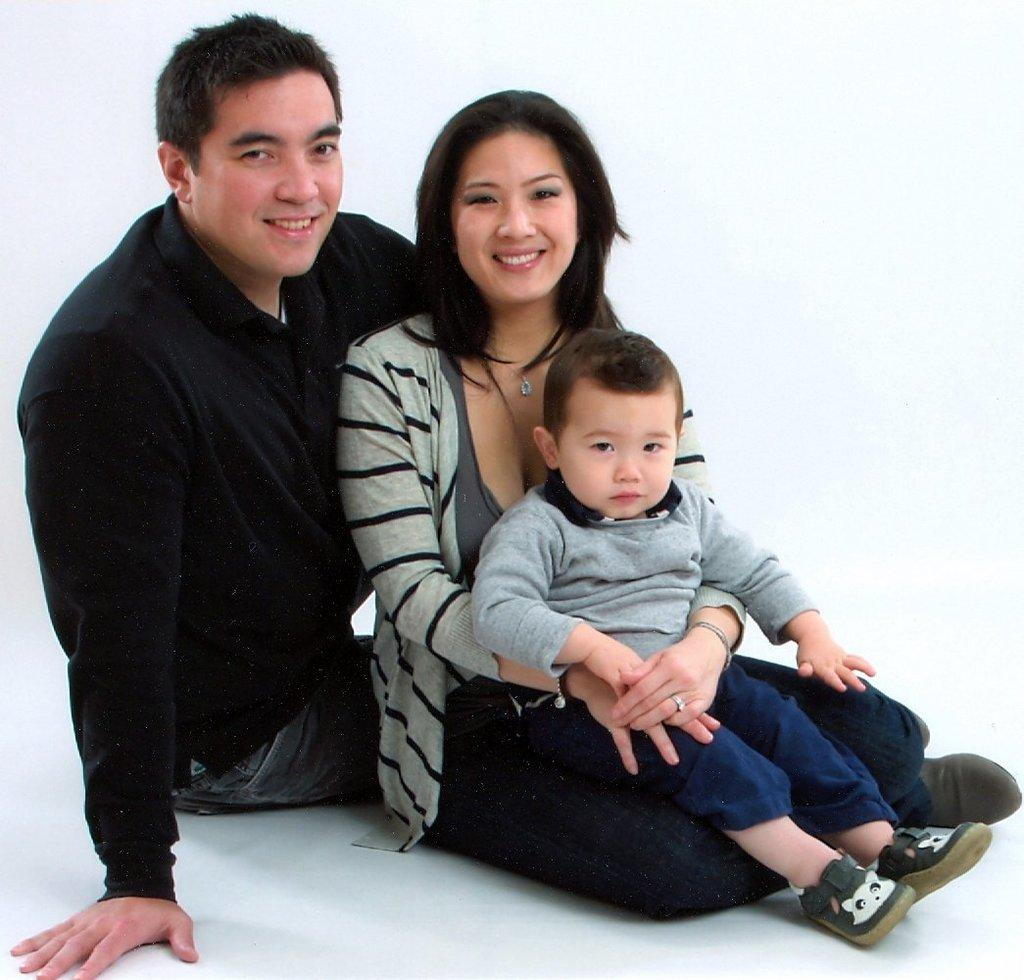How many people are present in the image? There are three individuals in the image: a man, a lady, and a boy. What is the facial expression of the people in the image? All three individuals are smiling in the image. What is at the bottom of the image? There is a surface at the bottom of the image. What type of oil is being used by the man in the image? There is no oil present in the image, and the man is not performing any activity that would involve using oil. 